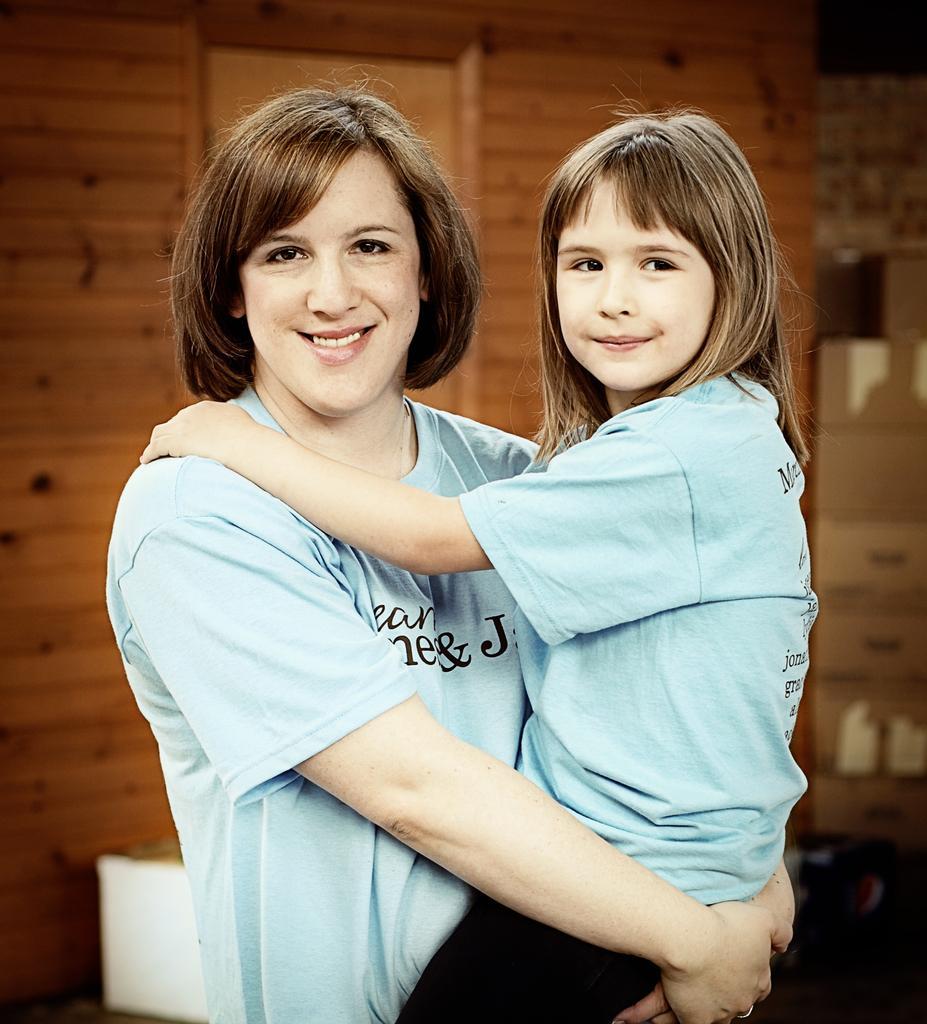Describe this image in one or two sentences. In this image I can see two people with the blue and black color dresses. These people are smiling. In the back I can see the wooden wall. To the side there are some cardboard boxes can be seen. 